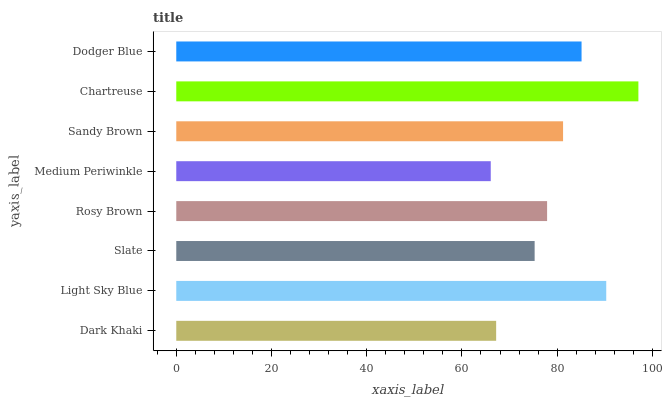Is Medium Periwinkle the minimum?
Answer yes or no. Yes. Is Chartreuse the maximum?
Answer yes or no. Yes. Is Light Sky Blue the minimum?
Answer yes or no. No. Is Light Sky Blue the maximum?
Answer yes or no. No. Is Light Sky Blue greater than Dark Khaki?
Answer yes or no. Yes. Is Dark Khaki less than Light Sky Blue?
Answer yes or no. Yes. Is Dark Khaki greater than Light Sky Blue?
Answer yes or no. No. Is Light Sky Blue less than Dark Khaki?
Answer yes or no. No. Is Sandy Brown the high median?
Answer yes or no. Yes. Is Rosy Brown the low median?
Answer yes or no. Yes. Is Light Sky Blue the high median?
Answer yes or no. No. Is Slate the low median?
Answer yes or no. No. 